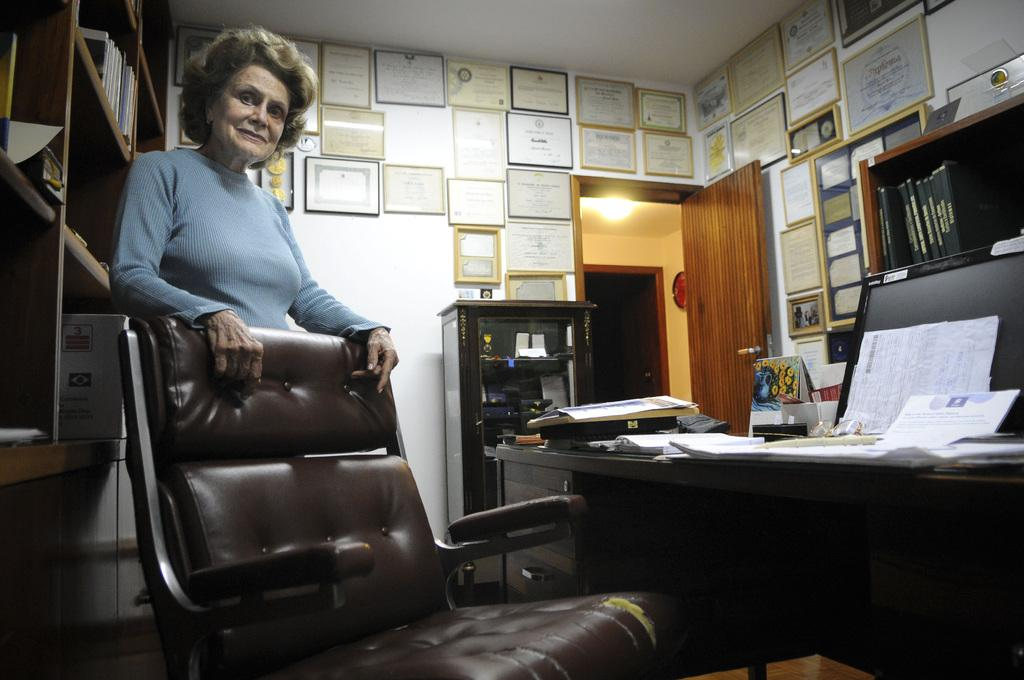Who is present in the image? There is a woman in the image. What is the woman's expression? The woman is smiling. What can be seen on the walls in the image? There are certificates on the walls. What type of furniture is present in the image? There is a chair and a table in the image. What electronic device is visible in the image? There is a monitor in the image. What type of paper items are present in the image? There are papers in the image. How does the woman say good-bye in the image? There is no indication of the woman saying good-bye in the image, as she is smiling and there is no context provided for her actions. 